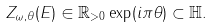<formula> <loc_0><loc_0><loc_500><loc_500>Z _ { \omega , \theta } ( E ) \in \mathbb { R } _ { > 0 } \exp ( i \pi \theta ) \subset \mathbb { H } .</formula> 